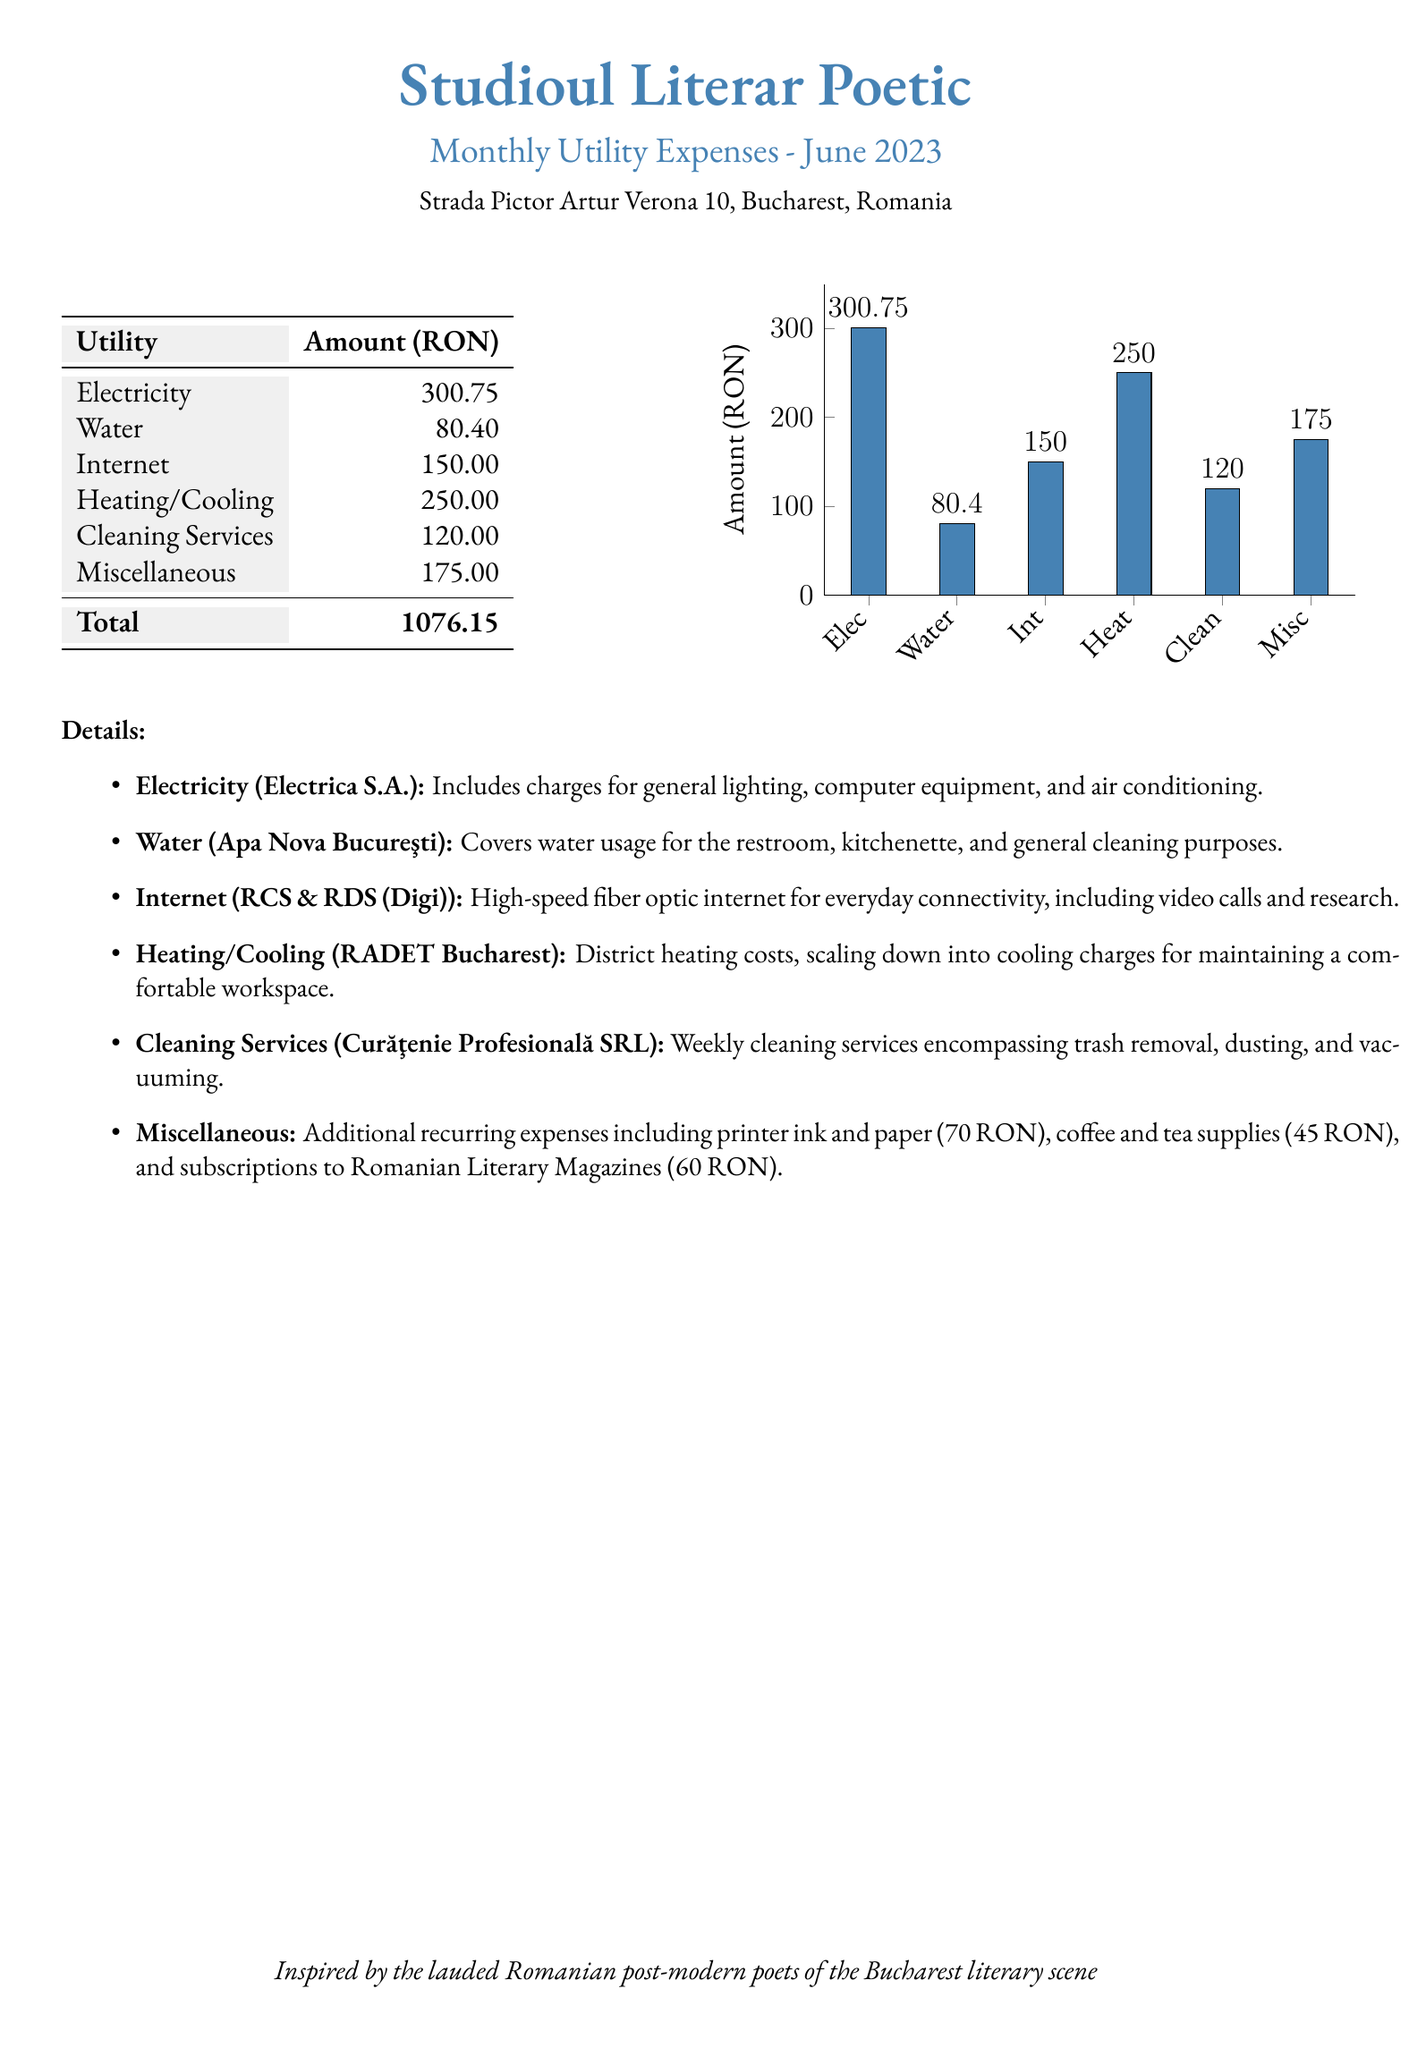What is the total amount for utility expenses? The total amount is found at the bottom of the expense table, which adds up all individual utility expenses.
Answer: 1076.15 How much is spent on electricity? This specific value is provided in the detailed breakdown for utility expenses.
Answer: 300.75 What is the cost of water? The cost is explicitly listed under the utility expenses in the document.
Answer: 80.40 Which service has the lowest expense? By comparing all the utility expenses, one can identify which one is the least.
Answer: Water What are the miscellaneous expenses? This is the sum of all additional recurring expenses mentioned in the details section of the document.
Answer: 175.00 What is included in the internet expense? The document specifies the internet type and provider within its details section.
Answer: High-speed fiber optic internet How much is allocated for heating and cooling? This amount is stated clearly under the utility expenses.
Answer: 250.00 Which company provides cleaning services? The document lists the company name in the details for cleaning services.
Answer: Curăţenie Profesională SRL How many utility categories are listed? The total number of unique utility expenses can be counted from the table.
Answer: 6 